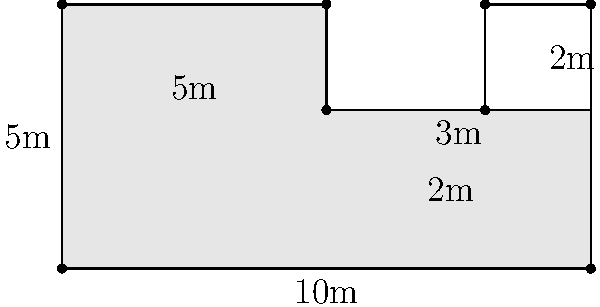As the mayor overseeing the expansion of maternal healthcare facilities, you need to calculate the total floor area of a new maternity ward. The ward has an irregular shape, as shown in the floor plan above. What is the total area of the maternity ward in square meters? To calculate the total area of the maternity ward, we need to break it down into simpler shapes and add their areas together:

1. Main rectangular area:
   Length = 10m, Width = 5m
   Area = $10m \times 5m = 50m^2$

2. Subtract the rectangular alcove:
   Length = 2m, Width = 2m
   Area to subtract = $2m \times 2m = 4m^2$

3. Calculate the total area:
   Total Area = Main rectangle - Alcove
   $$ \text{Total Area} = 50m^2 - 4m^2 = 46m^2 $$

Therefore, the total floor area of the maternity ward is 46 square meters.
Answer: $46m^2$ 